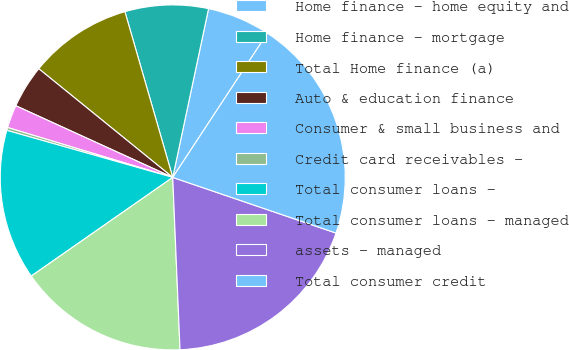<chart> <loc_0><loc_0><loc_500><loc_500><pie_chart><fcel>Home finance - home equity and<fcel>Home finance - mortgage<fcel>Total Home finance (a)<fcel>Auto & education finance<fcel>Consumer & small business and<fcel>Credit card receivables -<fcel>Total consumer loans -<fcel>Total consumer loans - managed<fcel>assets - managed<fcel>Total consumer credit<nl><fcel>5.92%<fcel>7.8%<fcel>9.68%<fcel>4.03%<fcel>2.15%<fcel>0.27%<fcel>14.09%<fcel>15.98%<fcel>19.1%<fcel>20.98%<nl></chart> 